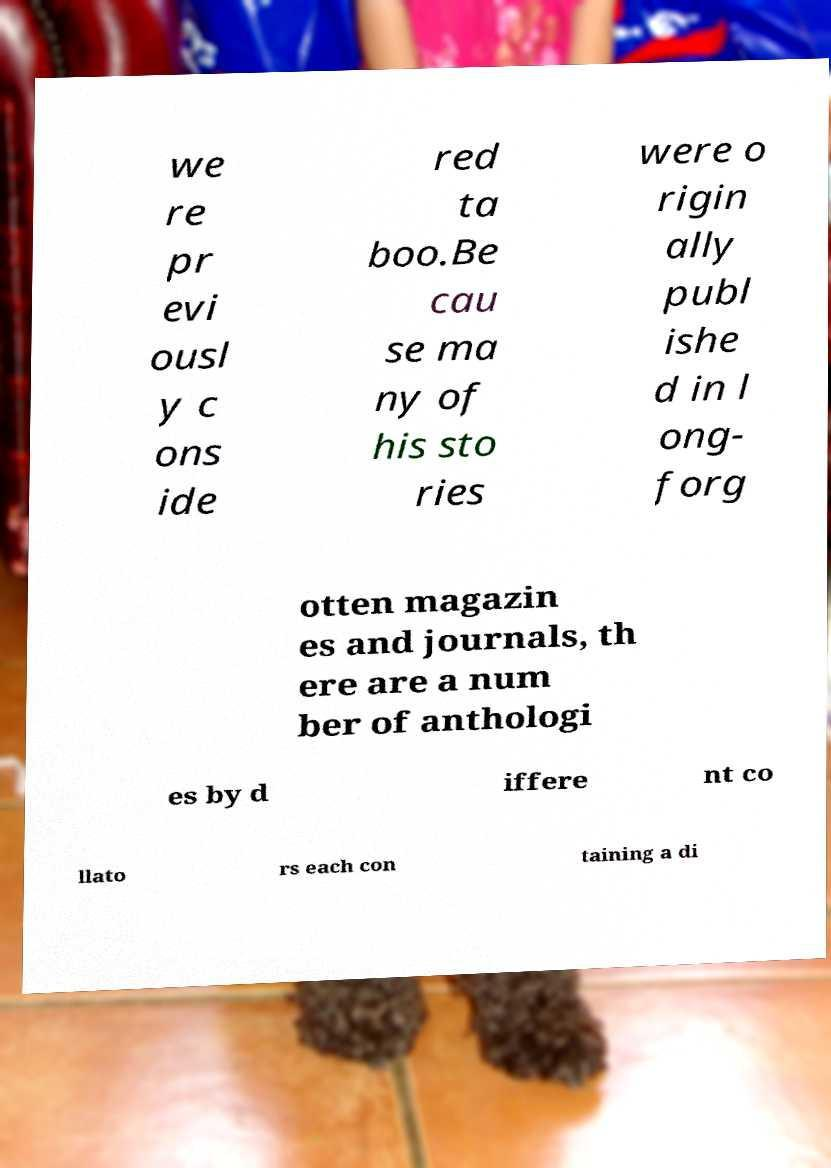Please read and relay the text visible in this image. What does it say? we re pr evi ousl y c ons ide red ta boo.Be cau se ma ny of his sto ries were o rigin ally publ ishe d in l ong- forg otten magazin es and journals, th ere are a num ber of anthologi es by d iffere nt co llato rs each con taining a di 